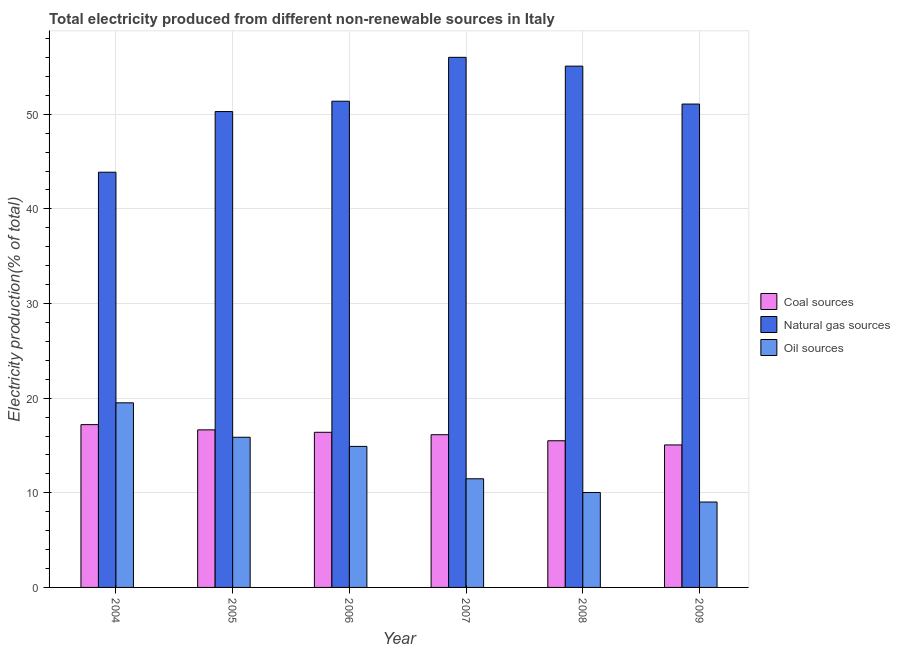How many groups of bars are there?
Offer a terse response. 6. Are the number of bars per tick equal to the number of legend labels?
Your answer should be very brief. Yes. Are the number of bars on each tick of the X-axis equal?
Provide a succinct answer. Yes. How many bars are there on the 6th tick from the right?
Your response must be concise. 3. What is the label of the 3rd group of bars from the left?
Offer a very short reply. 2006. In how many cases, is the number of bars for a given year not equal to the number of legend labels?
Provide a short and direct response. 0. What is the percentage of electricity produced by oil sources in 2006?
Ensure brevity in your answer.  14.9. Across all years, what is the maximum percentage of electricity produced by oil sources?
Offer a terse response. 19.51. Across all years, what is the minimum percentage of electricity produced by natural gas?
Offer a very short reply. 43.87. In which year was the percentage of electricity produced by natural gas maximum?
Keep it short and to the point. 2007. In which year was the percentage of electricity produced by coal minimum?
Your response must be concise. 2009. What is the total percentage of electricity produced by coal in the graph?
Ensure brevity in your answer.  96.93. What is the difference between the percentage of electricity produced by oil sources in 2005 and that in 2009?
Give a very brief answer. 6.84. What is the difference between the percentage of electricity produced by natural gas in 2007 and the percentage of electricity produced by coal in 2005?
Offer a very short reply. 5.73. What is the average percentage of electricity produced by natural gas per year?
Your response must be concise. 51.28. What is the ratio of the percentage of electricity produced by oil sources in 2008 to that in 2009?
Your answer should be compact. 1.11. What is the difference between the highest and the second highest percentage of electricity produced by coal?
Your answer should be very brief. 0.55. What is the difference between the highest and the lowest percentage of electricity produced by natural gas?
Give a very brief answer. 12.14. In how many years, is the percentage of electricity produced by oil sources greater than the average percentage of electricity produced by oil sources taken over all years?
Offer a terse response. 3. What does the 1st bar from the left in 2007 represents?
Provide a short and direct response. Coal sources. What does the 2nd bar from the right in 2005 represents?
Offer a very short reply. Natural gas sources. Are all the bars in the graph horizontal?
Provide a succinct answer. No. How many years are there in the graph?
Ensure brevity in your answer.  6. What is the title of the graph?
Your answer should be compact. Total electricity produced from different non-renewable sources in Italy. Does "Tertiary education" appear as one of the legend labels in the graph?
Your response must be concise. No. What is the label or title of the X-axis?
Offer a terse response. Year. What is the label or title of the Y-axis?
Offer a terse response. Electricity production(% of total). What is the Electricity production(% of total) of Coal sources in 2004?
Your answer should be compact. 17.2. What is the Electricity production(% of total) of Natural gas sources in 2004?
Your response must be concise. 43.87. What is the Electricity production(% of total) in Oil sources in 2004?
Make the answer very short. 19.51. What is the Electricity production(% of total) in Coal sources in 2005?
Offer a terse response. 16.65. What is the Electricity production(% of total) in Natural gas sources in 2005?
Your response must be concise. 50.28. What is the Electricity production(% of total) in Oil sources in 2005?
Provide a short and direct response. 15.87. What is the Electricity production(% of total) of Coal sources in 2006?
Make the answer very short. 16.39. What is the Electricity production(% of total) of Natural gas sources in 2006?
Offer a terse response. 51.38. What is the Electricity production(% of total) in Oil sources in 2006?
Provide a succinct answer. 14.9. What is the Electricity production(% of total) in Coal sources in 2007?
Make the answer very short. 16.14. What is the Electricity production(% of total) in Natural gas sources in 2007?
Offer a very short reply. 56.01. What is the Electricity production(% of total) of Oil sources in 2007?
Ensure brevity in your answer.  11.48. What is the Electricity production(% of total) of Coal sources in 2008?
Give a very brief answer. 15.5. What is the Electricity production(% of total) in Natural gas sources in 2008?
Your answer should be very brief. 55.08. What is the Electricity production(% of total) in Oil sources in 2008?
Give a very brief answer. 10.03. What is the Electricity production(% of total) in Coal sources in 2009?
Give a very brief answer. 15.06. What is the Electricity production(% of total) in Natural gas sources in 2009?
Keep it short and to the point. 51.08. What is the Electricity production(% of total) of Oil sources in 2009?
Your response must be concise. 9.02. Across all years, what is the maximum Electricity production(% of total) of Coal sources?
Your answer should be compact. 17.2. Across all years, what is the maximum Electricity production(% of total) of Natural gas sources?
Offer a terse response. 56.01. Across all years, what is the maximum Electricity production(% of total) in Oil sources?
Your response must be concise. 19.51. Across all years, what is the minimum Electricity production(% of total) of Coal sources?
Provide a succinct answer. 15.06. Across all years, what is the minimum Electricity production(% of total) of Natural gas sources?
Offer a terse response. 43.87. Across all years, what is the minimum Electricity production(% of total) of Oil sources?
Your answer should be compact. 9.02. What is the total Electricity production(% of total) in Coal sources in the graph?
Provide a short and direct response. 96.93. What is the total Electricity production(% of total) of Natural gas sources in the graph?
Ensure brevity in your answer.  307.71. What is the total Electricity production(% of total) of Oil sources in the graph?
Provide a short and direct response. 80.81. What is the difference between the Electricity production(% of total) of Coal sources in 2004 and that in 2005?
Provide a short and direct response. 0.55. What is the difference between the Electricity production(% of total) in Natural gas sources in 2004 and that in 2005?
Provide a succinct answer. -6.41. What is the difference between the Electricity production(% of total) in Oil sources in 2004 and that in 2005?
Provide a short and direct response. 3.64. What is the difference between the Electricity production(% of total) in Coal sources in 2004 and that in 2006?
Offer a very short reply. 0.81. What is the difference between the Electricity production(% of total) in Natural gas sources in 2004 and that in 2006?
Give a very brief answer. -7.5. What is the difference between the Electricity production(% of total) in Oil sources in 2004 and that in 2006?
Give a very brief answer. 4.6. What is the difference between the Electricity production(% of total) of Coal sources in 2004 and that in 2007?
Give a very brief answer. 1.06. What is the difference between the Electricity production(% of total) of Natural gas sources in 2004 and that in 2007?
Give a very brief answer. -12.14. What is the difference between the Electricity production(% of total) of Oil sources in 2004 and that in 2007?
Make the answer very short. 8.03. What is the difference between the Electricity production(% of total) in Coal sources in 2004 and that in 2008?
Ensure brevity in your answer.  1.7. What is the difference between the Electricity production(% of total) in Natural gas sources in 2004 and that in 2008?
Offer a terse response. -11.21. What is the difference between the Electricity production(% of total) in Oil sources in 2004 and that in 2008?
Offer a terse response. 9.47. What is the difference between the Electricity production(% of total) in Coal sources in 2004 and that in 2009?
Give a very brief answer. 2.14. What is the difference between the Electricity production(% of total) in Natural gas sources in 2004 and that in 2009?
Your answer should be very brief. -7.2. What is the difference between the Electricity production(% of total) in Oil sources in 2004 and that in 2009?
Keep it short and to the point. 10.48. What is the difference between the Electricity production(% of total) of Coal sources in 2005 and that in 2006?
Your response must be concise. 0.26. What is the difference between the Electricity production(% of total) of Natural gas sources in 2005 and that in 2006?
Make the answer very short. -1.09. What is the difference between the Electricity production(% of total) in Oil sources in 2005 and that in 2006?
Make the answer very short. 0.97. What is the difference between the Electricity production(% of total) of Coal sources in 2005 and that in 2007?
Make the answer very short. 0.51. What is the difference between the Electricity production(% of total) in Natural gas sources in 2005 and that in 2007?
Make the answer very short. -5.73. What is the difference between the Electricity production(% of total) of Oil sources in 2005 and that in 2007?
Give a very brief answer. 4.39. What is the difference between the Electricity production(% of total) in Coal sources in 2005 and that in 2008?
Provide a succinct answer. 1.15. What is the difference between the Electricity production(% of total) of Natural gas sources in 2005 and that in 2008?
Provide a short and direct response. -4.8. What is the difference between the Electricity production(% of total) in Oil sources in 2005 and that in 2008?
Give a very brief answer. 5.83. What is the difference between the Electricity production(% of total) of Coal sources in 2005 and that in 2009?
Provide a short and direct response. 1.59. What is the difference between the Electricity production(% of total) of Natural gas sources in 2005 and that in 2009?
Ensure brevity in your answer.  -0.79. What is the difference between the Electricity production(% of total) of Oil sources in 2005 and that in 2009?
Your response must be concise. 6.84. What is the difference between the Electricity production(% of total) of Coal sources in 2006 and that in 2007?
Offer a very short reply. 0.26. What is the difference between the Electricity production(% of total) in Natural gas sources in 2006 and that in 2007?
Your answer should be very brief. -4.64. What is the difference between the Electricity production(% of total) of Oil sources in 2006 and that in 2007?
Provide a succinct answer. 3.42. What is the difference between the Electricity production(% of total) in Coal sources in 2006 and that in 2008?
Make the answer very short. 0.89. What is the difference between the Electricity production(% of total) in Natural gas sources in 2006 and that in 2008?
Offer a terse response. -3.71. What is the difference between the Electricity production(% of total) of Oil sources in 2006 and that in 2008?
Make the answer very short. 4.87. What is the difference between the Electricity production(% of total) of Coal sources in 2006 and that in 2009?
Your answer should be very brief. 1.33. What is the difference between the Electricity production(% of total) of Natural gas sources in 2006 and that in 2009?
Provide a succinct answer. 0.3. What is the difference between the Electricity production(% of total) in Oil sources in 2006 and that in 2009?
Keep it short and to the point. 5.88. What is the difference between the Electricity production(% of total) of Coal sources in 2007 and that in 2008?
Keep it short and to the point. 0.64. What is the difference between the Electricity production(% of total) in Natural gas sources in 2007 and that in 2008?
Offer a very short reply. 0.93. What is the difference between the Electricity production(% of total) in Oil sources in 2007 and that in 2008?
Keep it short and to the point. 1.45. What is the difference between the Electricity production(% of total) of Coal sources in 2007 and that in 2009?
Provide a short and direct response. 1.08. What is the difference between the Electricity production(% of total) of Natural gas sources in 2007 and that in 2009?
Your answer should be compact. 4.94. What is the difference between the Electricity production(% of total) of Oil sources in 2007 and that in 2009?
Your answer should be compact. 2.46. What is the difference between the Electricity production(% of total) of Coal sources in 2008 and that in 2009?
Make the answer very short. 0.44. What is the difference between the Electricity production(% of total) in Natural gas sources in 2008 and that in 2009?
Your response must be concise. 4.01. What is the difference between the Electricity production(% of total) in Oil sources in 2008 and that in 2009?
Offer a very short reply. 1.01. What is the difference between the Electricity production(% of total) in Coal sources in 2004 and the Electricity production(% of total) in Natural gas sources in 2005?
Offer a very short reply. -33.08. What is the difference between the Electricity production(% of total) in Coal sources in 2004 and the Electricity production(% of total) in Oil sources in 2005?
Your answer should be very brief. 1.33. What is the difference between the Electricity production(% of total) in Natural gas sources in 2004 and the Electricity production(% of total) in Oil sources in 2005?
Your response must be concise. 28.01. What is the difference between the Electricity production(% of total) in Coal sources in 2004 and the Electricity production(% of total) in Natural gas sources in 2006?
Provide a succinct answer. -34.17. What is the difference between the Electricity production(% of total) of Coal sources in 2004 and the Electricity production(% of total) of Oil sources in 2006?
Your response must be concise. 2.3. What is the difference between the Electricity production(% of total) in Natural gas sources in 2004 and the Electricity production(% of total) in Oil sources in 2006?
Offer a terse response. 28.97. What is the difference between the Electricity production(% of total) of Coal sources in 2004 and the Electricity production(% of total) of Natural gas sources in 2007?
Offer a very short reply. -38.81. What is the difference between the Electricity production(% of total) in Coal sources in 2004 and the Electricity production(% of total) in Oil sources in 2007?
Provide a short and direct response. 5.72. What is the difference between the Electricity production(% of total) of Natural gas sources in 2004 and the Electricity production(% of total) of Oil sources in 2007?
Make the answer very short. 32.39. What is the difference between the Electricity production(% of total) in Coal sources in 2004 and the Electricity production(% of total) in Natural gas sources in 2008?
Keep it short and to the point. -37.88. What is the difference between the Electricity production(% of total) in Coal sources in 2004 and the Electricity production(% of total) in Oil sources in 2008?
Your answer should be compact. 7.17. What is the difference between the Electricity production(% of total) of Natural gas sources in 2004 and the Electricity production(% of total) of Oil sources in 2008?
Provide a short and direct response. 33.84. What is the difference between the Electricity production(% of total) of Coal sources in 2004 and the Electricity production(% of total) of Natural gas sources in 2009?
Your answer should be compact. -33.87. What is the difference between the Electricity production(% of total) of Coal sources in 2004 and the Electricity production(% of total) of Oil sources in 2009?
Your response must be concise. 8.18. What is the difference between the Electricity production(% of total) of Natural gas sources in 2004 and the Electricity production(% of total) of Oil sources in 2009?
Provide a succinct answer. 34.85. What is the difference between the Electricity production(% of total) of Coal sources in 2005 and the Electricity production(% of total) of Natural gas sources in 2006?
Provide a succinct answer. -34.73. What is the difference between the Electricity production(% of total) of Coal sources in 2005 and the Electricity production(% of total) of Oil sources in 2006?
Make the answer very short. 1.75. What is the difference between the Electricity production(% of total) of Natural gas sources in 2005 and the Electricity production(% of total) of Oil sources in 2006?
Ensure brevity in your answer.  35.38. What is the difference between the Electricity production(% of total) in Coal sources in 2005 and the Electricity production(% of total) in Natural gas sources in 2007?
Your response must be concise. -39.37. What is the difference between the Electricity production(% of total) of Coal sources in 2005 and the Electricity production(% of total) of Oil sources in 2007?
Give a very brief answer. 5.17. What is the difference between the Electricity production(% of total) of Natural gas sources in 2005 and the Electricity production(% of total) of Oil sources in 2007?
Provide a short and direct response. 38.8. What is the difference between the Electricity production(% of total) of Coal sources in 2005 and the Electricity production(% of total) of Natural gas sources in 2008?
Offer a very short reply. -38.43. What is the difference between the Electricity production(% of total) of Coal sources in 2005 and the Electricity production(% of total) of Oil sources in 2008?
Provide a short and direct response. 6.62. What is the difference between the Electricity production(% of total) in Natural gas sources in 2005 and the Electricity production(% of total) in Oil sources in 2008?
Your response must be concise. 40.25. What is the difference between the Electricity production(% of total) in Coal sources in 2005 and the Electricity production(% of total) in Natural gas sources in 2009?
Make the answer very short. -34.43. What is the difference between the Electricity production(% of total) in Coal sources in 2005 and the Electricity production(% of total) in Oil sources in 2009?
Your response must be concise. 7.62. What is the difference between the Electricity production(% of total) of Natural gas sources in 2005 and the Electricity production(% of total) of Oil sources in 2009?
Ensure brevity in your answer.  41.26. What is the difference between the Electricity production(% of total) of Coal sources in 2006 and the Electricity production(% of total) of Natural gas sources in 2007?
Your response must be concise. -39.62. What is the difference between the Electricity production(% of total) in Coal sources in 2006 and the Electricity production(% of total) in Oil sources in 2007?
Offer a very short reply. 4.91. What is the difference between the Electricity production(% of total) of Natural gas sources in 2006 and the Electricity production(% of total) of Oil sources in 2007?
Your response must be concise. 39.9. What is the difference between the Electricity production(% of total) of Coal sources in 2006 and the Electricity production(% of total) of Natural gas sources in 2008?
Offer a terse response. -38.69. What is the difference between the Electricity production(% of total) in Coal sources in 2006 and the Electricity production(% of total) in Oil sources in 2008?
Provide a succinct answer. 6.36. What is the difference between the Electricity production(% of total) in Natural gas sources in 2006 and the Electricity production(% of total) in Oil sources in 2008?
Keep it short and to the point. 41.34. What is the difference between the Electricity production(% of total) in Coal sources in 2006 and the Electricity production(% of total) in Natural gas sources in 2009?
Give a very brief answer. -34.68. What is the difference between the Electricity production(% of total) in Coal sources in 2006 and the Electricity production(% of total) in Oil sources in 2009?
Keep it short and to the point. 7.37. What is the difference between the Electricity production(% of total) in Natural gas sources in 2006 and the Electricity production(% of total) in Oil sources in 2009?
Offer a terse response. 42.35. What is the difference between the Electricity production(% of total) of Coal sources in 2007 and the Electricity production(% of total) of Natural gas sources in 2008?
Your answer should be compact. -38.95. What is the difference between the Electricity production(% of total) in Coal sources in 2007 and the Electricity production(% of total) in Oil sources in 2008?
Keep it short and to the point. 6.1. What is the difference between the Electricity production(% of total) of Natural gas sources in 2007 and the Electricity production(% of total) of Oil sources in 2008?
Your answer should be very brief. 45.98. What is the difference between the Electricity production(% of total) of Coal sources in 2007 and the Electricity production(% of total) of Natural gas sources in 2009?
Provide a succinct answer. -34.94. What is the difference between the Electricity production(% of total) of Coal sources in 2007 and the Electricity production(% of total) of Oil sources in 2009?
Offer a terse response. 7.11. What is the difference between the Electricity production(% of total) of Natural gas sources in 2007 and the Electricity production(% of total) of Oil sources in 2009?
Keep it short and to the point. 46.99. What is the difference between the Electricity production(% of total) in Coal sources in 2008 and the Electricity production(% of total) in Natural gas sources in 2009?
Provide a short and direct response. -35.58. What is the difference between the Electricity production(% of total) of Coal sources in 2008 and the Electricity production(% of total) of Oil sources in 2009?
Your answer should be compact. 6.47. What is the difference between the Electricity production(% of total) in Natural gas sources in 2008 and the Electricity production(% of total) in Oil sources in 2009?
Provide a succinct answer. 46.06. What is the average Electricity production(% of total) of Coal sources per year?
Your answer should be compact. 16.16. What is the average Electricity production(% of total) in Natural gas sources per year?
Offer a terse response. 51.28. What is the average Electricity production(% of total) of Oil sources per year?
Your answer should be compact. 13.47. In the year 2004, what is the difference between the Electricity production(% of total) of Coal sources and Electricity production(% of total) of Natural gas sources?
Offer a terse response. -26.67. In the year 2004, what is the difference between the Electricity production(% of total) of Coal sources and Electricity production(% of total) of Oil sources?
Give a very brief answer. -2.31. In the year 2004, what is the difference between the Electricity production(% of total) of Natural gas sources and Electricity production(% of total) of Oil sources?
Your response must be concise. 24.37. In the year 2005, what is the difference between the Electricity production(% of total) of Coal sources and Electricity production(% of total) of Natural gas sources?
Your answer should be very brief. -33.64. In the year 2005, what is the difference between the Electricity production(% of total) in Coal sources and Electricity production(% of total) in Oil sources?
Offer a terse response. 0.78. In the year 2005, what is the difference between the Electricity production(% of total) in Natural gas sources and Electricity production(% of total) in Oil sources?
Your answer should be compact. 34.42. In the year 2006, what is the difference between the Electricity production(% of total) in Coal sources and Electricity production(% of total) in Natural gas sources?
Make the answer very short. -34.98. In the year 2006, what is the difference between the Electricity production(% of total) in Coal sources and Electricity production(% of total) in Oil sources?
Your answer should be very brief. 1.49. In the year 2006, what is the difference between the Electricity production(% of total) in Natural gas sources and Electricity production(% of total) in Oil sources?
Keep it short and to the point. 36.47. In the year 2007, what is the difference between the Electricity production(% of total) of Coal sources and Electricity production(% of total) of Natural gas sources?
Keep it short and to the point. -39.88. In the year 2007, what is the difference between the Electricity production(% of total) of Coal sources and Electricity production(% of total) of Oil sources?
Offer a very short reply. 4.66. In the year 2007, what is the difference between the Electricity production(% of total) in Natural gas sources and Electricity production(% of total) in Oil sources?
Ensure brevity in your answer.  44.53. In the year 2008, what is the difference between the Electricity production(% of total) of Coal sources and Electricity production(% of total) of Natural gas sources?
Provide a succinct answer. -39.58. In the year 2008, what is the difference between the Electricity production(% of total) of Coal sources and Electricity production(% of total) of Oil sources?
Offer a very short reply. 5.47. In the year 2008, what is the difference between the Electricity production(% of total) in Natural gas sources and Electricity production(% of total) in Oil sources?
Your answer should be compact. 45.05. In the year 2009, what is the difference between the Electricity production(% of total) in Coal sources and Electricity production(% of total) in Natural gas sources?
Offer a terse response. -36.02. In the year 2009, what is the difference between the Electricity production(% of total) in Coal sources and Electricity production(% of total) in Oil sources?
Provide a short and direct response. 6.03. In the year 2009, what is the difference between the Electricity production(% of total) of Natural gas sources and Electricity production(% of total) of Oil sources?
Offer a very short reply. 42.05. What is the ratio of the Electricity production(% of total) in Coal sources in 2004 to that in 2005?
Your answer should be very brief. 1.03. What is the ratio of the Electricity production(% of total) in Natural gas sources in 2004 to that in 2005?
Provide a succinct answer. 0.87. What is the ratio of the Electricity production(% of total) of Oil sources in 2004 to that in 2005?
Offer a very short reply. 1.23. What is the ratio of the Electricity production(% of total) in Coal sources in 2004 to that in 2006?
Ensure brevity in your answer.  1.05. What is the ratio of the Electricity production(% of total) in Natural gas sources in 2004 to that in 2006?
Your response must be concise. 0.85. What is the ratio of the Electricity production(% of total) in Oil sources in 2004 to that in 2006?
Give a very brief answer. 1.31. What is the ratio of the Electricity production(% of total) of Coal sources in 2004 to that in 2007?
Your answer should be compact. 1.07. What is the ratio of the Electricity production(% of total) of Natural gas sources in 2004 to that in 2007?
Provide a short and direct response. 0.78. What is the ratio of the Electricity production(% of total) in Oil sources in 2004 to that in 2007?
Offer a very short reply. 1.7. What is the ratio of the Electricity production(% of total) in Coal sources in 2004 to that in 2008?
Your response must be concise. 1.11. What is the ratio of the Electricity production(% of total) of Natural gas sources in 2004 to that in 2008?
Offer a very short reply. 0.8. What is the ratio of the Electricity production(% of total) in Oil sources in 2004 to that in 2008?
Make the answer very short. 1.94. What is the ratio of the Electricity production(% of total) in Coal sources in 2004 to that in 2009?
Your response must be concise. 1.14. What is the ratio of the Electricity production(% of total) in Natural gas sources in 2004 to that in 2009?
Offer a terse response. 0.86. What is the ratio of the Electricity production(% of total) of Oil sources in 2004 to that in 2009?
Your answer should be very brief. 2.16. What is the ratio of the Electricity production(% of total) in Coal sources in 2005 to that in 2006?
Ensure brevity in your answer.  1.02. What is the ratio of the Electricity production(% of total) of Natural gas sources in 2005 to that in 2006?
Keep it short and to the point. 0.98. What is the ratio of the Electricity production(% of total) of Oil sources in 2005 to that in 2006?
Your answer should be very brief. 1.06. What is the ratio of the Electricity production(% of total) in Coal sources in 2005 to that in 2007?
Ensure brevity in your answer.  1.03. What is the ratio of the Electricity production(% of total) in Natural gas sources in 2005 to that in 2007?
Make the answer very short. 0.9. What is the ratio of the Electricity production(% of total) of Oil sources in 2005 to that in 2007?
Keep it short and to the point. 1.38. What is the ratio of the Electricity production(% of total) of Coal sources in 2005 to that in 2008?
Your answer should be very brief. 1.07. What is the ratio of the Electricity production(% of total) of Natural gas sources in 2005 to that in 2008?
Ensure brevity in your answer.  0.91. What is the ratio of the Electricity production(% of total) in Oil sources in 2005 to that in 2008?
Offer a very short reply. 1.58. What is the ratio of the Electricity production(% of total) of Coal sources in 2005 to that in 2009?
Provide a succinct answer. 1.11. What is the ratio of the Electricity production(% of total) of Natural gas sources in 2005 to that in 2009?
Provide a short and direct response. 0.98. What is the ratio of the Electricity production(% of total) in Oil sources in 2005 to that in 2009?
Provide a short and direct response. 1.76. What is the ratio of the Electricity production(% of total) in Coal sources in 2006 to that in 2007?
Your answer should be very brief. 1.02. What is the ratio of the Electricity production(% of total) in Natural gas sources in 2006 to that in 2007?
Ensure brevity in your answer.  0.92. What is the ratio of the Electricity production(% of total) of Oil sources in 2006 to that in 2007?
Provide a short and direct response. 1.3. What is the ratio of the Electricity production(% of total) in Coal sources in 2006 to that in 2008?
Ensure brevity in your answer.  1.06. What is the ratio of the Electricity production(% of total) in Natural gas sources in 2006 to that in 2008?
Your response must be concise. 0.93. What is the ratio of the Electricity production(% of total) in Oil sources in 2006 to that in 2008?
Give a very brief answer. 1.49. What is the ratio of the Electricity production(% of total) of Coal sources in 2006 to that in 2009?
Give a very brief answer. 1.09. What is the ratio of the Electricity production(% of total) in Natural gas sources in 2006 to that in 2009?
Offer a very short reply. 1.01. What is the ratio of the Electricity production(% of total) of Oil sources in 2006 to that in 2009?
Offer a very short reply. 1.65. What is the ratio of the Electricity production(% of total) of Coal sources in 2007 to that in 2008?
Offer a very short reply. 1.04. What is the ratio of the Electricity production(% of total) of Natural gas sources in 2007 to that in 2008?
Offer a very short reply. 1.02. What is the ratio of the Electricity production(% of total) of Oil sources in 2007 to that in 2008?
Make the answer very short. 1.14. What is the ratio of the Electricity production(% of total) in Coal sources in 2007 to that in 2009?
Offer a very short reply. 1.07. What is the ratio of the Electricity production(% of total) in Natural gas sources in 2007 to that in 2009?
Offer a terse response. 1.1. What is the ratio of the Electricity production(% of total) in Oil sources in 2007 to that in 2009?
Keep it short and to the point. 1.27. What is the ratio of the Electricity production(% of total) of Coal sources in 2008 to that in 2009?
Your answer should be very brief. 1.03. What is the ratio of the Electricity production(% of total) in Natural gas sources in 2008 to that in 2009?
Keep it short and to the point. 1.08. What is the ratio of the Electricity production(% of total) in Oil sources in 2008 to that in 2009?
Offer a terse response. 1.11. What is the difference between the highest and the second highest Electricity production(% of total) of Coal sources?
Make the answer very short. 0.55. What is the difference between the highest and the second highest Electricity production(% of total) of Natural gas sources?
Provide a short and direct response. 0.93. What is the difference between the highest and the second highest Electricity production(% of total) of Oil sources?
Your answer should be very brief. 3.64. What is the difference between the highest and the lowest Electricity production(% of total) in Coal sources?
Your answer should be very brief. 2.14. What is the difference between the highest and the lowest Electricity production(% of total) in Natural gas sources?
Your answer should be very brief. 12.14. What is the difference between the highest and the lowest Electricity production(% of total) of Oil sources?
Offer a terse response. 10.48. 